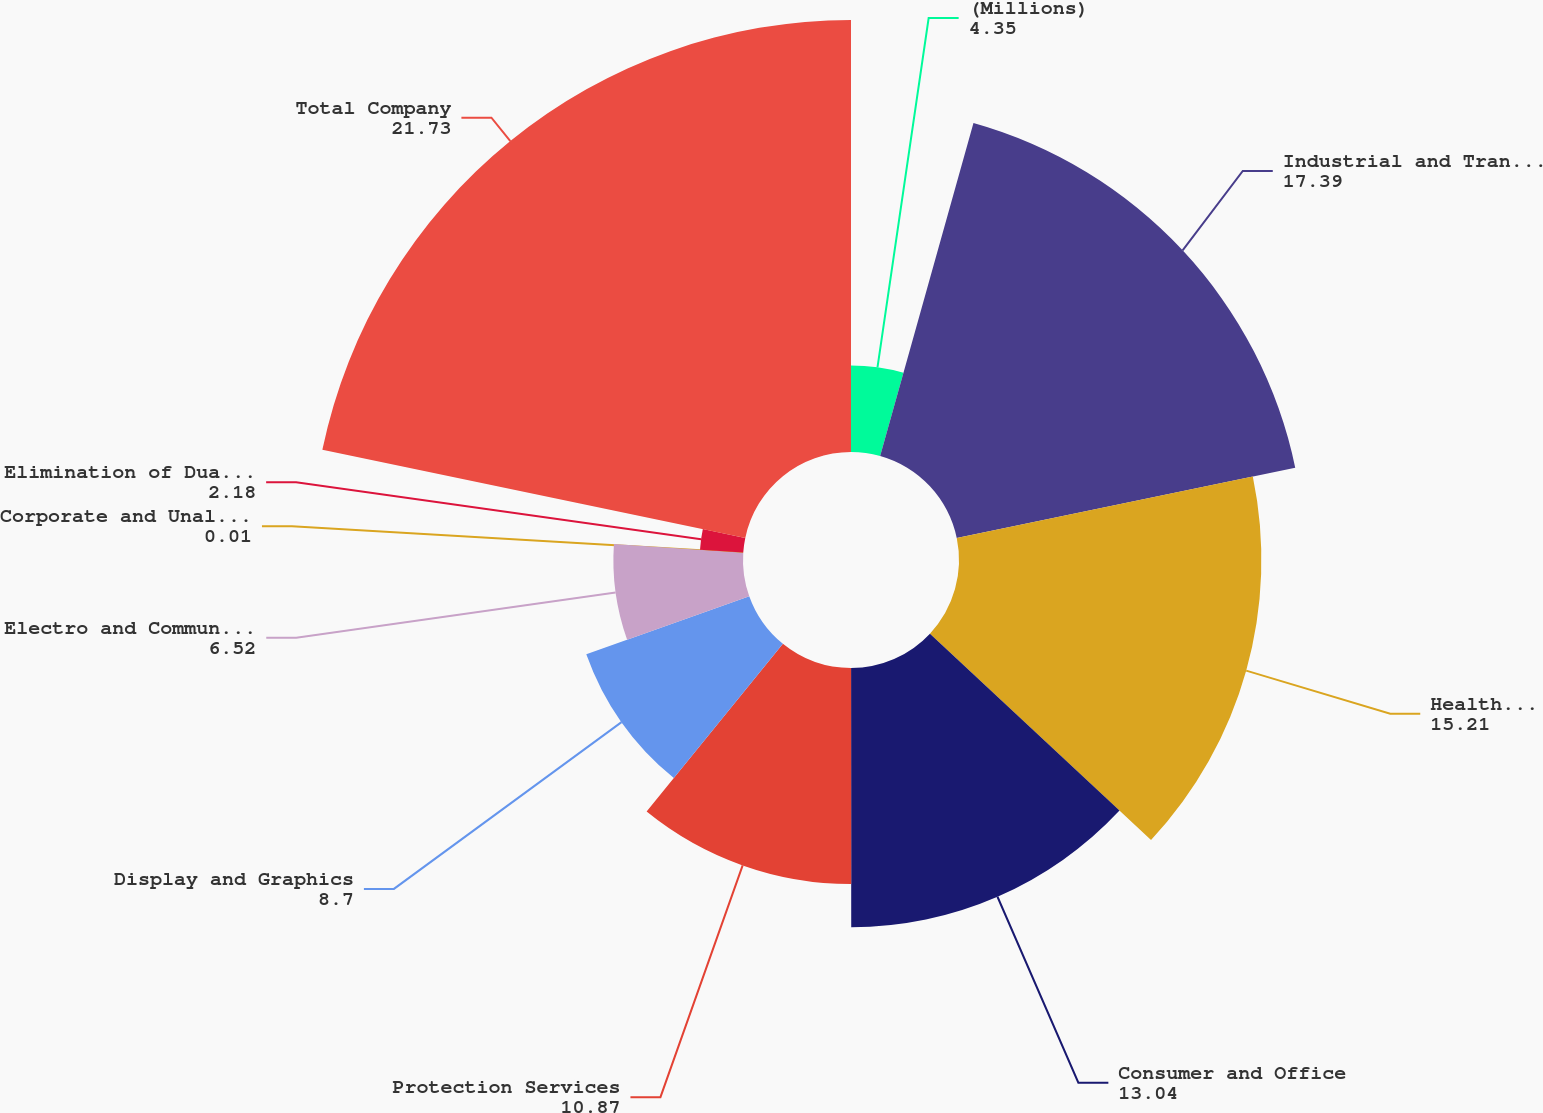<chart> <loc_0><loc_0><loc_500><loc_500><pie_chart><fcel>(Millions)<fcel>Industrial and Transportation<fcel>Health Care<fcel>Consumer and Office<fcel>Protection Services<fcel>Display and Graphics<fcel>Electro and Communications<fcel>Corporate and Unallocated<fcel>Elimination of Dual Credit<fcel>Total Company<nl><fcel>4.35%<fcel>17.39%<fcel>15.21%<fcel>13.04%<fcel>10.87%<fcel>8.7%<fcel>6.52%<fcel>0.01%<fcel>2.18%<fcel>21.73%<nl></chart> 